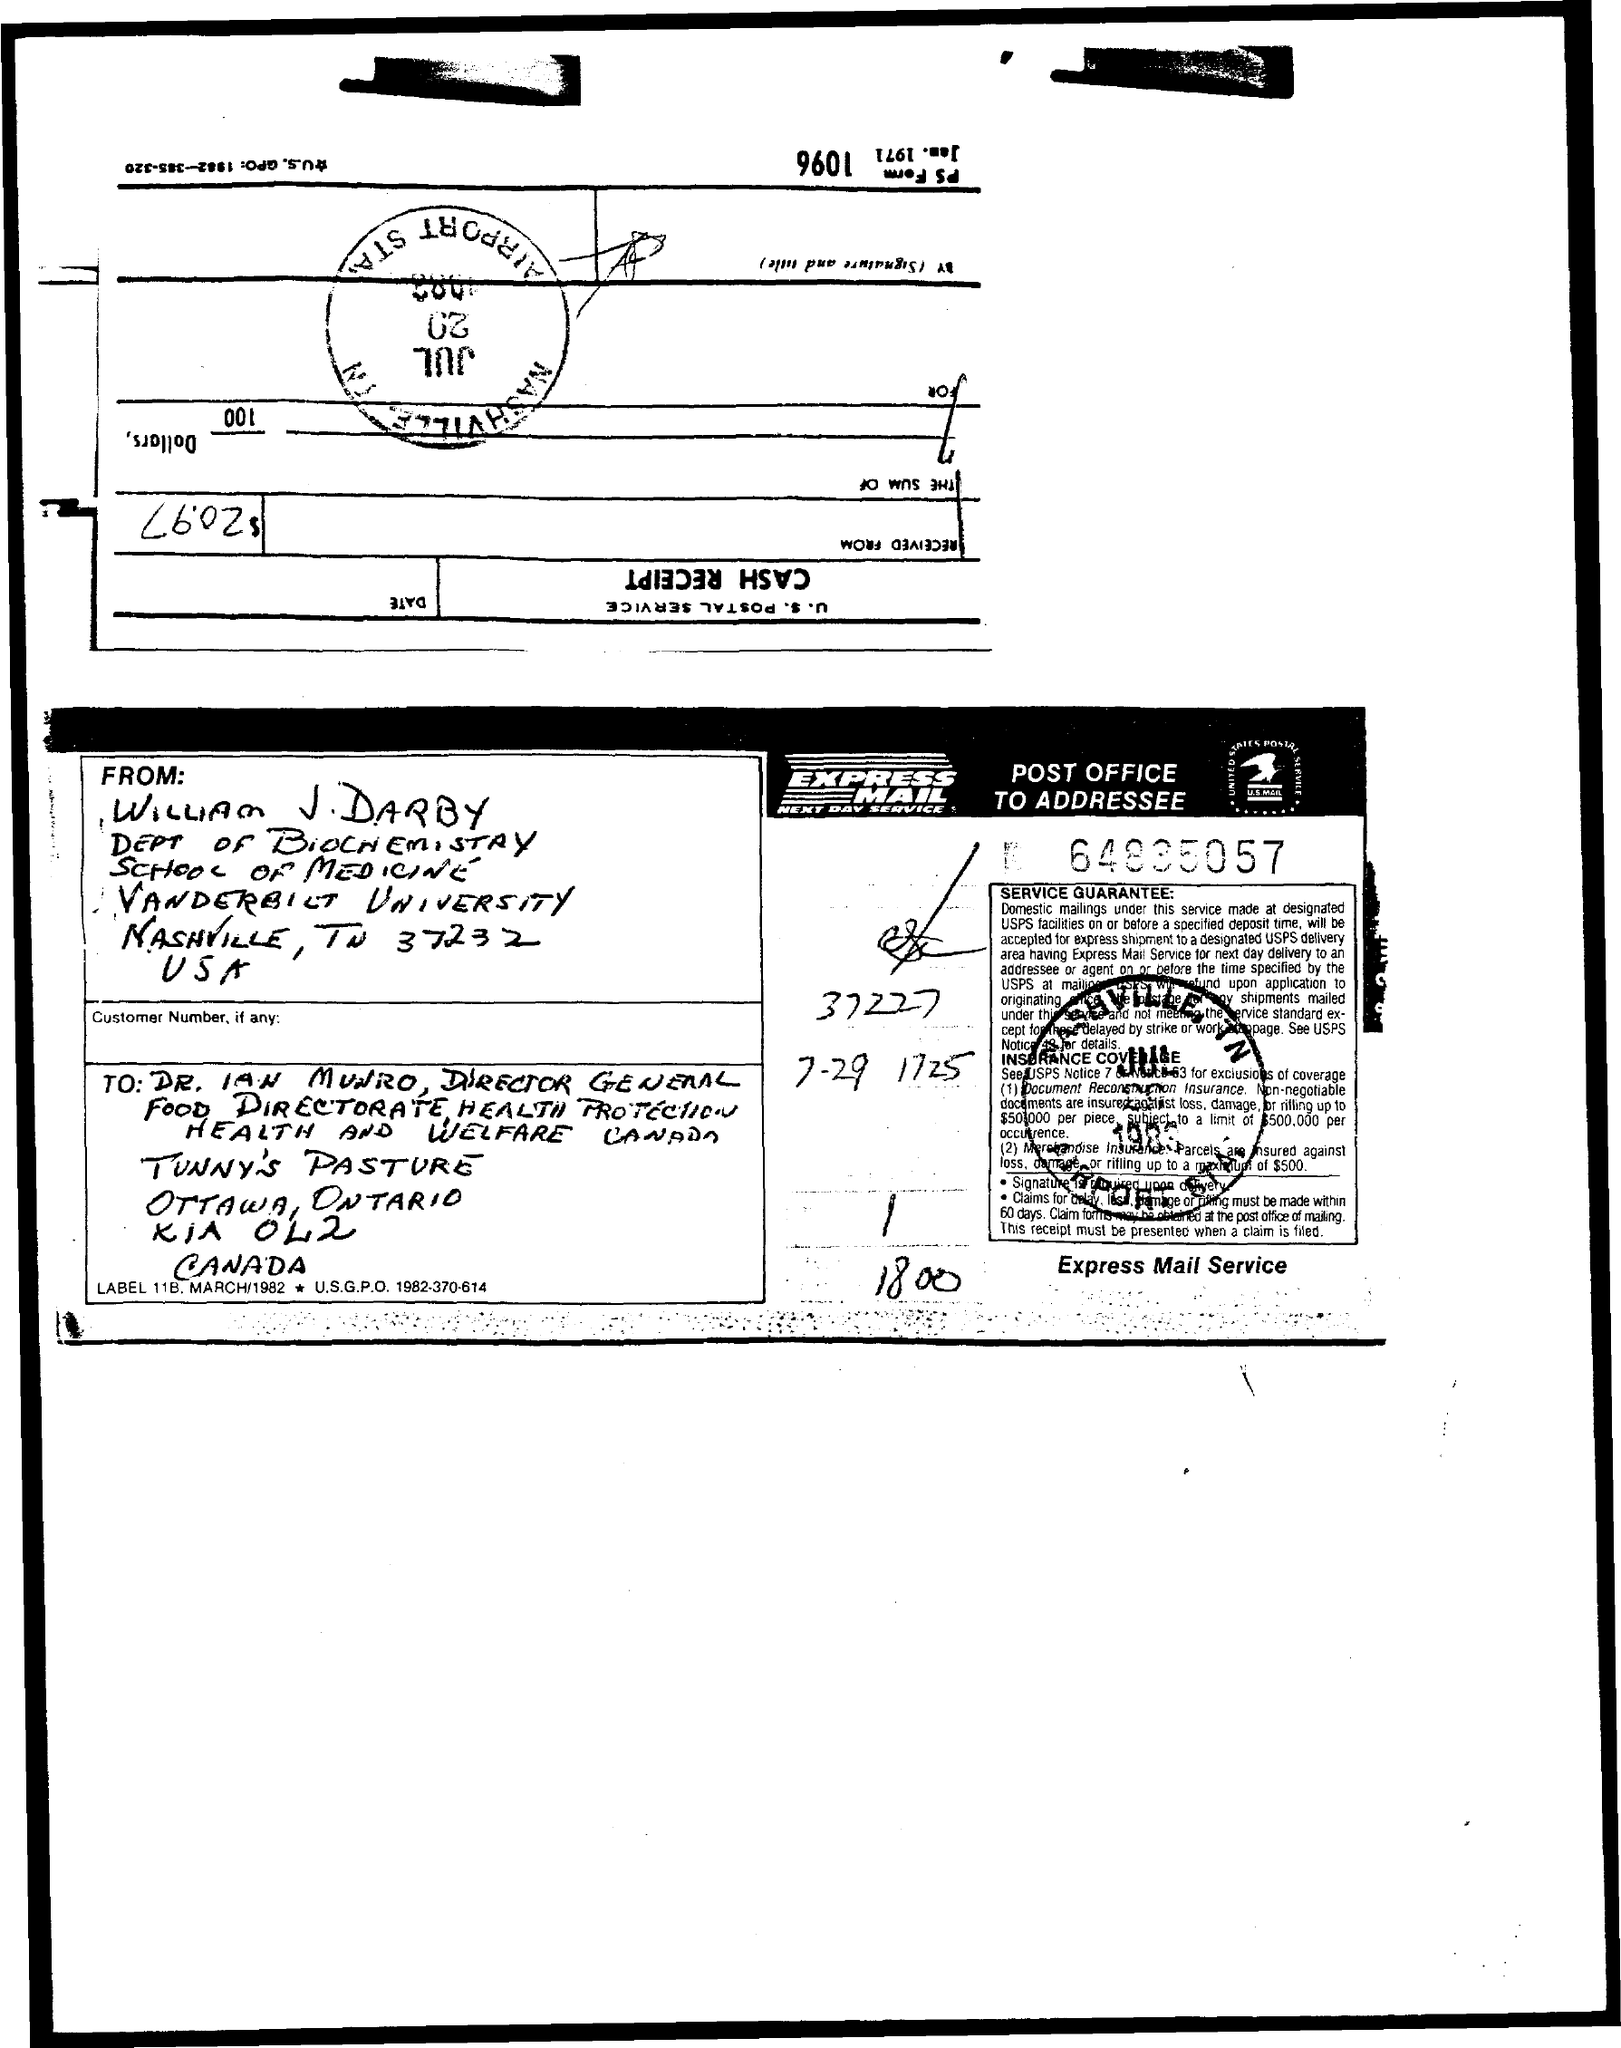From whom the mail was written ?
Your answer should be very brief. William J Darby. To which department william j darby belongs to ?
Give a very brief answer. Dept of biochemistry. To whom the mail was written ?
Provide a short and direct response. Dr. ian munro. 